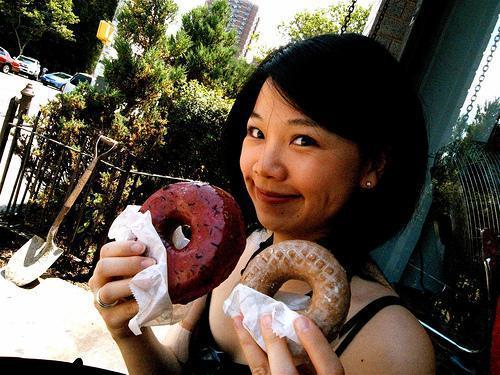How many doughnuts is she holding?
Give a very brief answer. 2. How many fingernails are visible?
Give a very brief answer. 5. How many donuts are there?
Give a very brief answer. 2. 